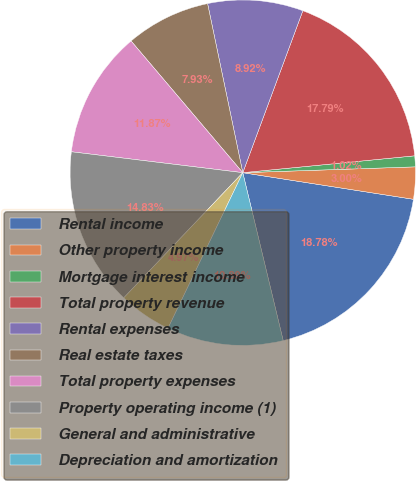Convert chart to OTSL. <chart><loc_0><loc_0><loc_500><loc_500><pie_chart><fcel>Rental income<fcel>Other property income<fcel>Mortgage interest income<fcel>Total property revenue<fcel>Rental expenses<fcel>Real estate taxes<fcel>Total property expenses<fcel>Property operating income (1)<fcel>General and administrative<fcel>Depreciation and amortization<nl><fcel>18.78%<fcel>3.0%<fcel>1.02%<fcel>17.79%<fcel>8.92%<fcel>7.93%<fcel>11.87%<fcel>14.83%<fcel>4.97%<fcel>10.89%<nl></chart> 